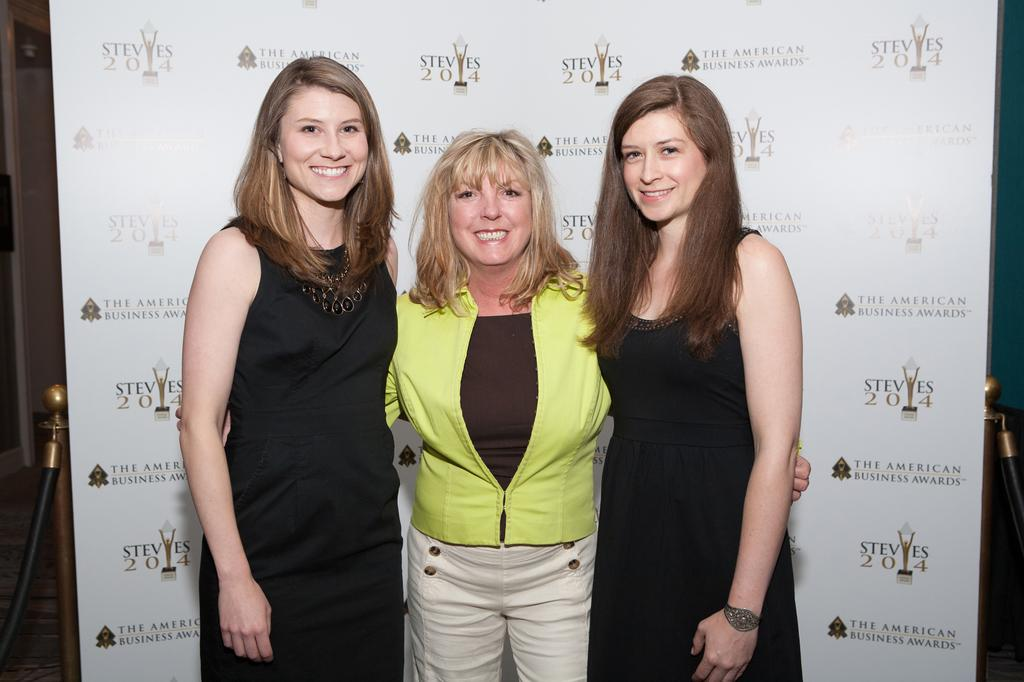How many people are in the center of the image? There are three ladies in the center of the image. What are the ladies doing in the image? The ladies are standing and smiling. What can be seen in the background of the image? There is a board in the background of the image. Do the ladies have any regrets about their actions in the image? There is no indication of regret in the image, as the ladies are smiling and no actions are described. Can you see any tails on the ladies in the image? There are no tails visible on the ladies in the image. 